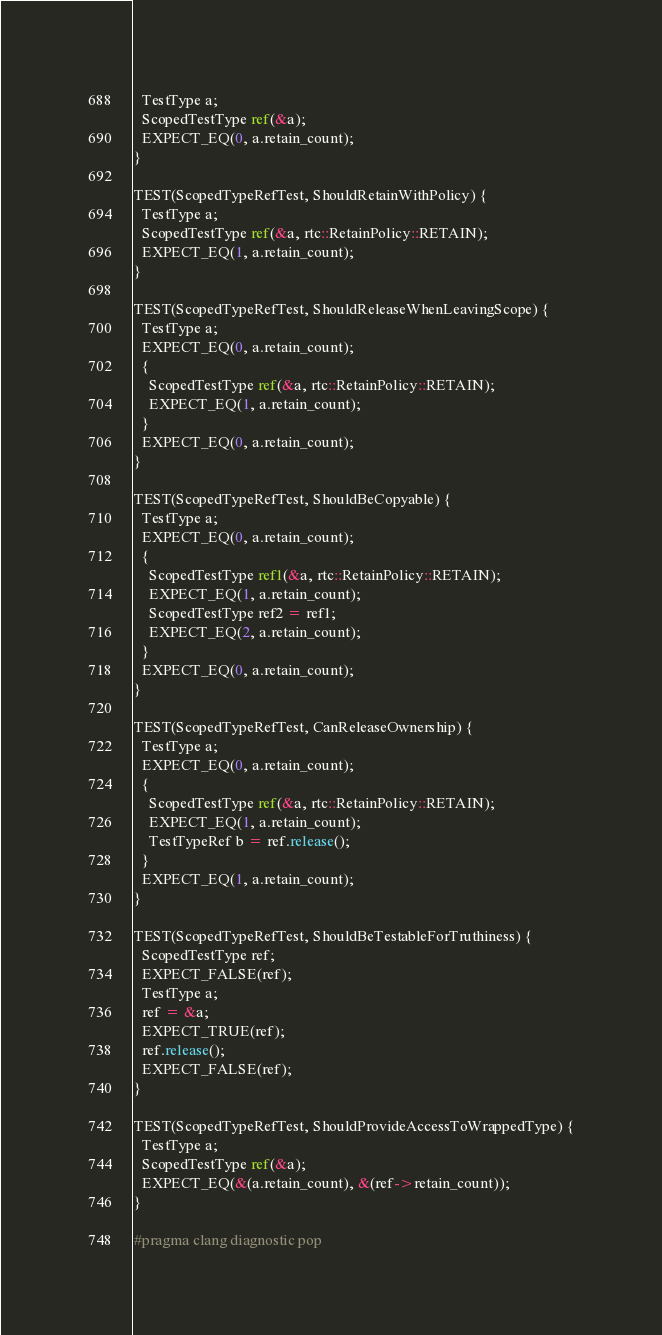Convert code to text. <code><loc_0><loc_0><loc_500><loc_500><_ObjectiveC_>  TestType a;
  ScopedTestType ref(&a);
  EXPECT_EQ(0, a.retain_count);
}

TEST(ScopedTypeRefTest, ShouldRetainWithPolicy) {
  TestType a;
  ScopedTestType ref(&a, rtc::RetainPolicy::RETAIN);
  EXPECT_EQ(1, a.retain_count);
}

TEST(ScopedTypeRefTest, ShouldReleaseWhenLeavingScope) {
  TestType a;
  EXPECT_EQ(0, a.retain_count);
  {
    ScopedTestType ref(&a, rtc::RetainPolicy::RETAIN);
    EXPECT_EQ(1, a.retain_count);
  }
  EXPECT_EQ(0, a.retain_count);
}

TEST(ScopedTypeRefTest, ShouldBeCopyable) {
  TestType a;
  EXPECT_EQ(0, a.retain_count);
  {
    ScopedTestType ref1(&a, rtc::RetainPolicy::RETAIN);
    EXPECT_EQ(1, a.retain_count);
    ScopedTestType ref2 = ref1;
    EXPECT_EQ(2, a.retain_count);
  }
  EXPECT_EQ(0, a.retain_count);
}

TEST(ScopedTypeRefTest, CanReleaseOwnership) {
  TestType a;
  EXPECT_EQ(0, a.retain_count);
  {
    ScopedTestType ref(&a, rtc::RetainPolicy::RETAIN);
    EXPECT_EQ(1, a.retain_count);
    TestTypeRef b = ref.release();
  }
  EXPECT_EQ(1, a.retain_count);
}

TEST(ScopedTypeRefTest, ShouldBeTestableForTruthiness) {
  ScopedTestType ref;
  EXPECT_FALSE(ref);
  TestType a;
  ref = &a;
  EXPECT_TRUE(ref);
  ref.release();
  EXPECT_FALSE(ref);
}

TEST(ScopedTypeRefTest, ShouldProvideAccessToWrappedType) {
  TestType a;
  ScopedTestType ref(&a);
  EXPECT_EQ(&(a.retain_count), &(ref->retain_count));
}

#pragma clang diagnostic pop
</code> 